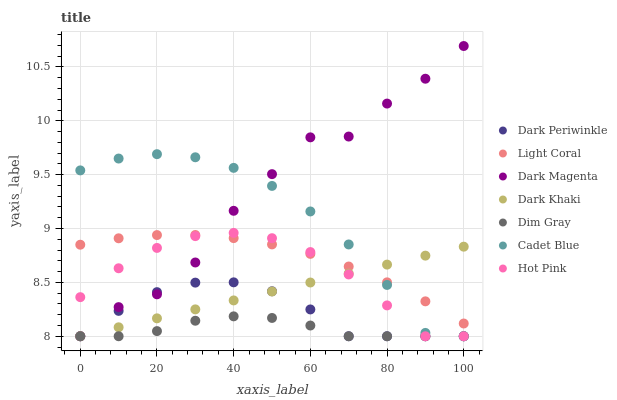Does Dim Gray have the minimum area under the curve?
Answer yes or no. Yes. Does Dark Magenta have the maximum area under the curve?
Answer yes or no. Yes. Does Dark Magenta have the minimum area under the curve?
Answer yes or no. No. Does Dim Gray have the maximum area under the curve?
Answer yes or no. No. Is Dark Khaki the smoothest?
Answer yes or no. Yes. Is Dark Magenta the roughest?
Answer yes or no. Yes. Is Dim Gray the smoothest?
Answer yes or no. No. Is Dim Gray the roughest?
Answer yes or no. No. Does Dark Khaki have the lowest value?
Answer yes or no. Yes. Does Light Coral have the lowest value?
Answer yes or no. No. Does Dark Magenta have the highest value?
Answer yes or no. Yes. Does Dim Gray have the highest value?
Answer yes or no. No. Is Dark Periwinkle less than Light Coral?
Answer yes or no. Yes. Is Light Coral greater than Dark Periwinkle?
Answer yes or no. Yes. Does Dark Magenta intersect Dark Khaki?
Answer yes or no. Yes. Is Dark Magenta less than Dark Khaki?
Answer yes or no. No. Is Dark Magenta greater than Dark Khaki?
Answer yes or no. No. Does Dark Periwinkle intersect Light Coral?
Answer yes or no. No. 